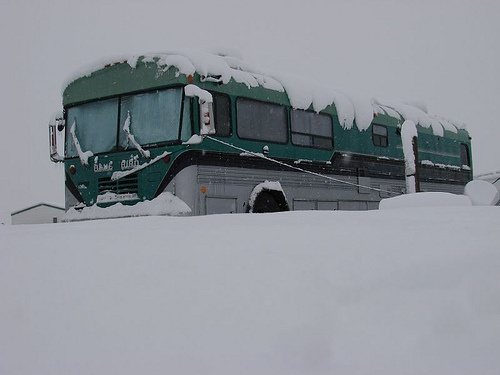Describe the objects in this image and their specific colors. I can see bus in darkgray, black, gray, and purple tones in this image. 